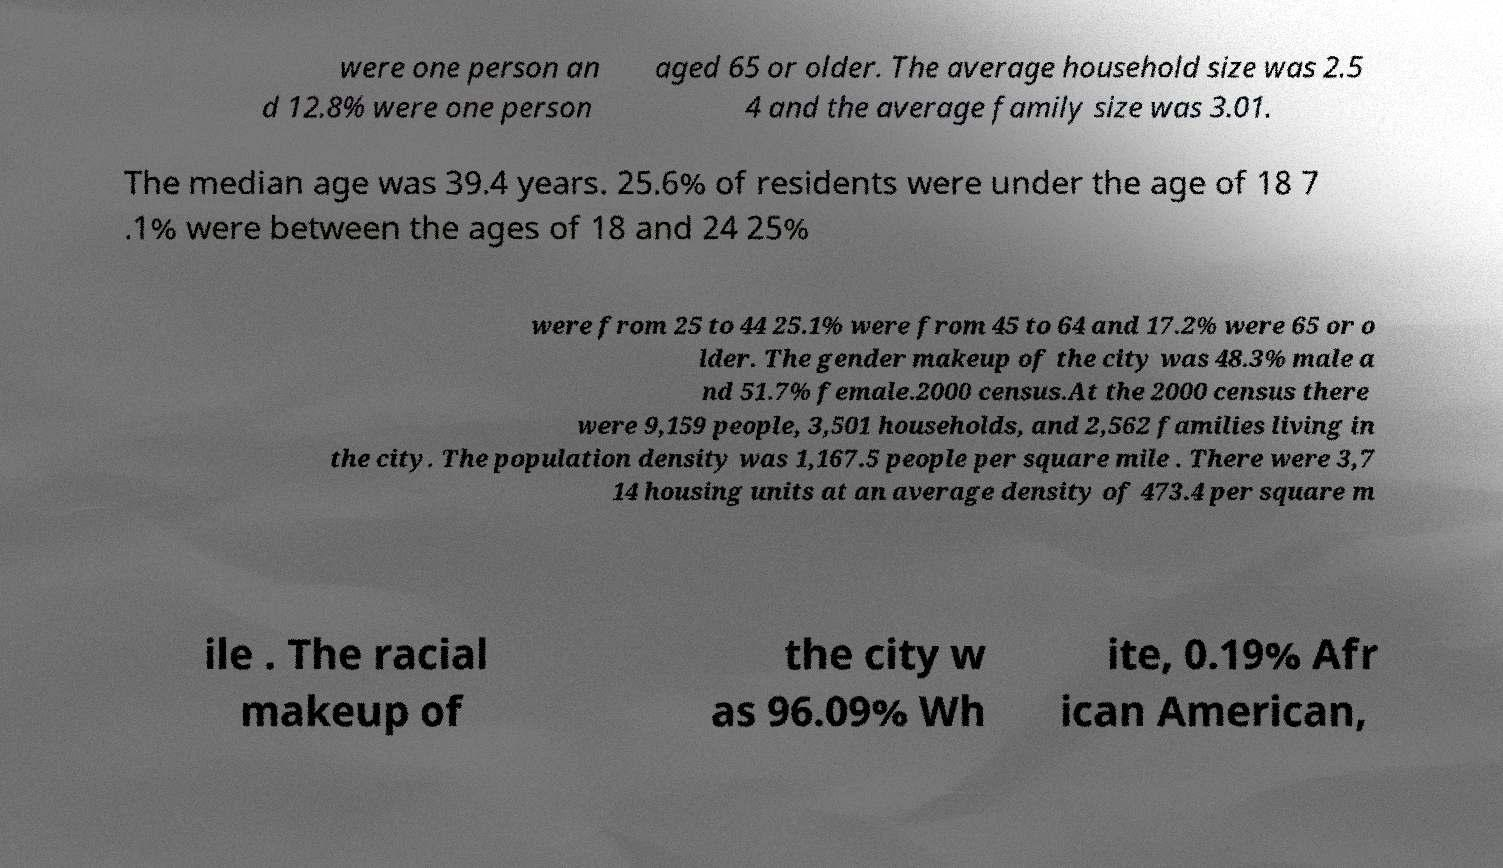Can you accurately transcribe the text from the provided image for me? were one person an d 12.8% were one person aged 65 or older. The average household size was 2.5 4 and the average family size was 3.01. The median age was 39.4 years. 25.6% of residents were under the age of 18 7 .1% were between the ages of 18 and 24 25% were from 25 to 44 25.1% were from 45 to 64 and 17.2% were 65 or o lder. The gender makeup of the city was 48.3% male a nd 51.7% female.2000 census.At the 2000 census there were 9,159 people, 3,501 households, and 2,562 families living in the city. The population density was 1,167.5 people per square mile . There were 3,7 14 housing units at an average density of 473.4 per square m ile . The racial makeup of the city w as 96.09% Wh ite, 0.19% Afr ican American, 